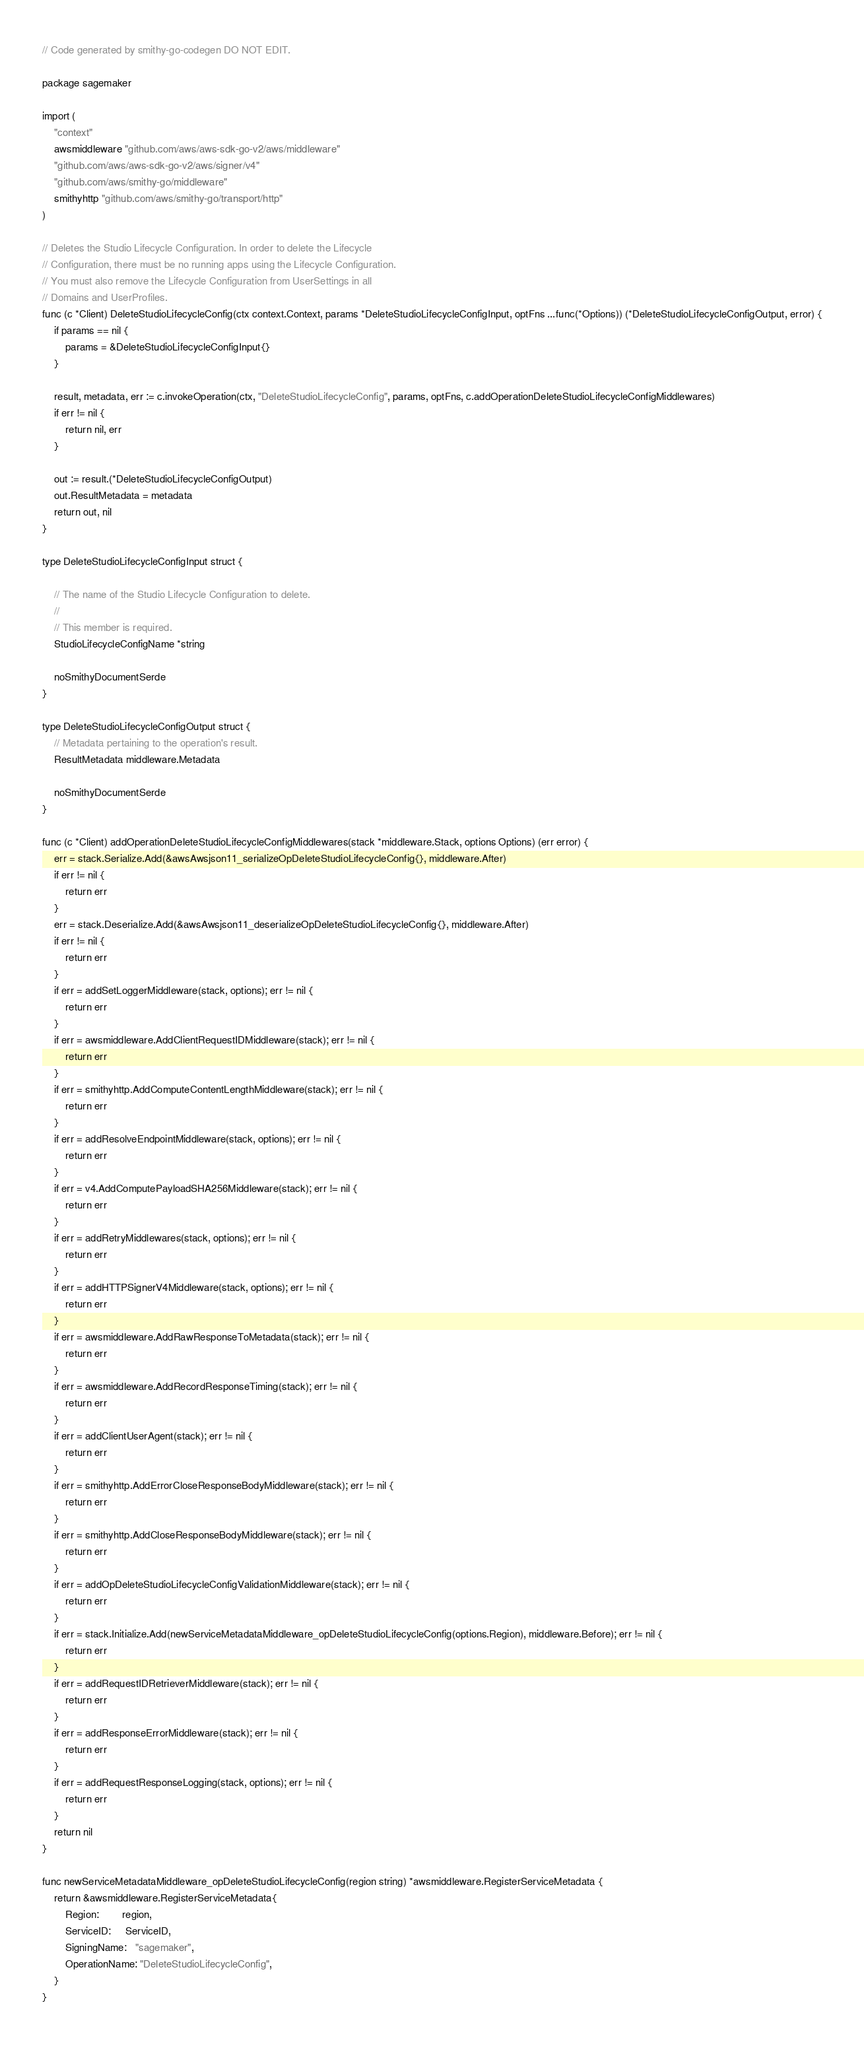<code> <loc_0><loc_0><loc_500><loc_500><_Go_>// Code generated by smithy-go-codegen DO NOT EDIT.

package sagemaker

import (
	"context"
	awsmiddleware "github.com/aws/aws-sdk-go-v2/aws/middleware"
	"github.com/aws/aws-sdk-go-v2/aws/signer/v4"
	"github.com/aws/smithy-go/middleware"
	smithyhttp "github.com/aws/smithy-go/transport/http"
)

// Deletes the Studio Lifecycle Configuration. In order to delete the Lifecycle
// Configuration, there must be no running apps using the Lifecycle Configuration.
// You must also remove the Lifecycle Configuration from UserSettings in all
// Domains and UserProfiles.
func (c *Client) DeleteStudioLifecycleConfig(ctx context.Context, params *DeleteStudioLifecycleConfigInput, optFns ...func(*Options)) (*DeleteStudioLifecycleConfigOutput, error) {
	if params == nil {
		params = &DeleteStudioLifecycleConfigInput{}
	}

	result, metadata, err := c.invokeOperation(ctx, "DeleteStudioLifecycleConfig", params, optFns, c.addOperationDeleteStudioLifecycleConfigMiddlewares)
	if err != nil {
		return nil, err
	}

	out := result.(*DeleteStudioLifecycleConfigOutput)
	out.ResultMetadata = metadata
	return out, nil
}

type DeleteStudioLifecycleConfigInput struct {

	// The name of the Studio Lifecycle Configuration to delete.
	//
	// This member is required.
	StudioLifecycleConfigName *string

	noSmithyDocumentSerde
}

type DeleteStudioLifecycleConfigOutput struct {
	// Metadata pertaining to the operation's result.
	ResultMetadata middleware.Metadata

	noSmithyDocumentSerde
}

func (c *Client) addOperationDeleteStudioLifecycleConfigMiddlewares(stack *middleware.Stack, options Options) (err error) {
	err = stack.Serialize.Add(&awsAwsjson11_serializeOpDeleteStudioLifecycleConfig{}, middleware.After)
	if err != nil {
		return err
	}
	err = stack.Deserialize.Add(&awsAwsjson11_deserializeOpDeleteStudioLifecycleConfig{}, middleware.After)
	if err != nil {
		return err
	}
	if err = addSetLoggerMiddleware(stack, options); err != nil {
		return err
	}
	if err = awsmiddleware.AddClientRequestIDMiddleware(stack); err != nil {
		return err
	}
	if err = smithyhttp.AddComputeContentLengthMiddleware(stack); err != nil {
		return err
	}
	if err = addResolveEndpointMiddleware(stack, options); err != nil {
		return err
	}
	if err = v4.AddComputePayloadSHA256Middleware(stack); err != nil {
		return err
	}
	if err = addRetryMiddlewares(stack, options); err != nil {
		return err
	}
	if err = addHTTPSignerV4Middleware(stack, options); err != nil {
		return err
	}
	if err = awsmiddleware.AddRawResponseToMetadata(stack); err != nil {
		return err
	}
	if err = awsmiddleware.AddRecordResponseTiming(stack); err != nil {
		return err
	}
	if err = addClientUserAgent(stack); err != nil {
		return err
	}
	if err = smithyhttp.AddErrorCloseResponseBodyMiddleware(stack); err != nil {
		return err
	}
	if err = smithyhttp.AddCloseResponseBodyMiddleware(stack); err != nil {
		return err
	}
	if err = addOpDeleteStudioLifecycleConfigValidationMiddleware(stack); err != nil {
		return err
	}
	if err = stack.Initialize.Add(newServiceMetadataMiddleware_opDeleteStudioLifecycleConfig(options.Region), middleware.Before); err != nil {
		return err
	}
	if err = addRequestIDRetrieverMiddleware(stack); err != nil {
		return err
	}
	if err = addResponseErrorMiddleware(stack); err != nil {
		return err
	}
	if err = addRequestResponseLogging(stack, options); err != nil {
		return err
	}
	return nil
}

func newServiceMetadataMiddleware_opDeleteStudioLifecycleConfig(region string) *awsmiddleware.RegisterServiceMetadata {
	return &awsmiddleware.RegisterServiceMetadata{
		Region:        region,
		ServiceID:     ServiceID,
		SigningName:   "sagemaker",
		OperationName: "DeleteStudioLifecycleConfig",
	}
}
</code> 